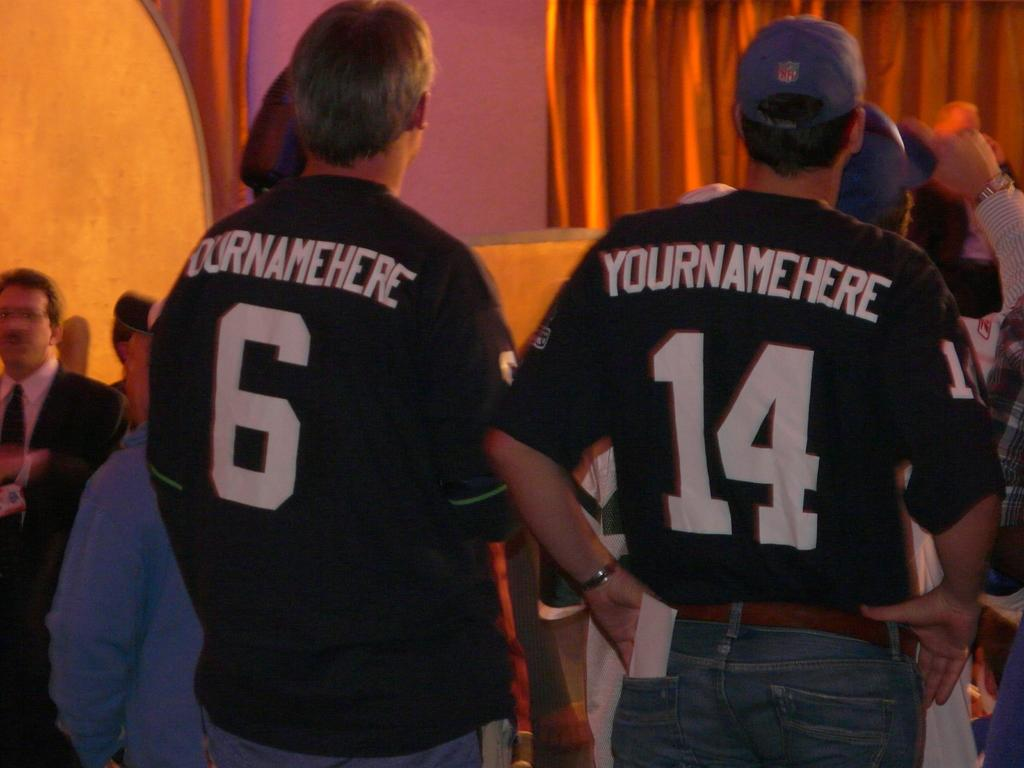<image>
Give a short and clear explanation of the subsequent image. men wear jersey with yournamehere on the back 